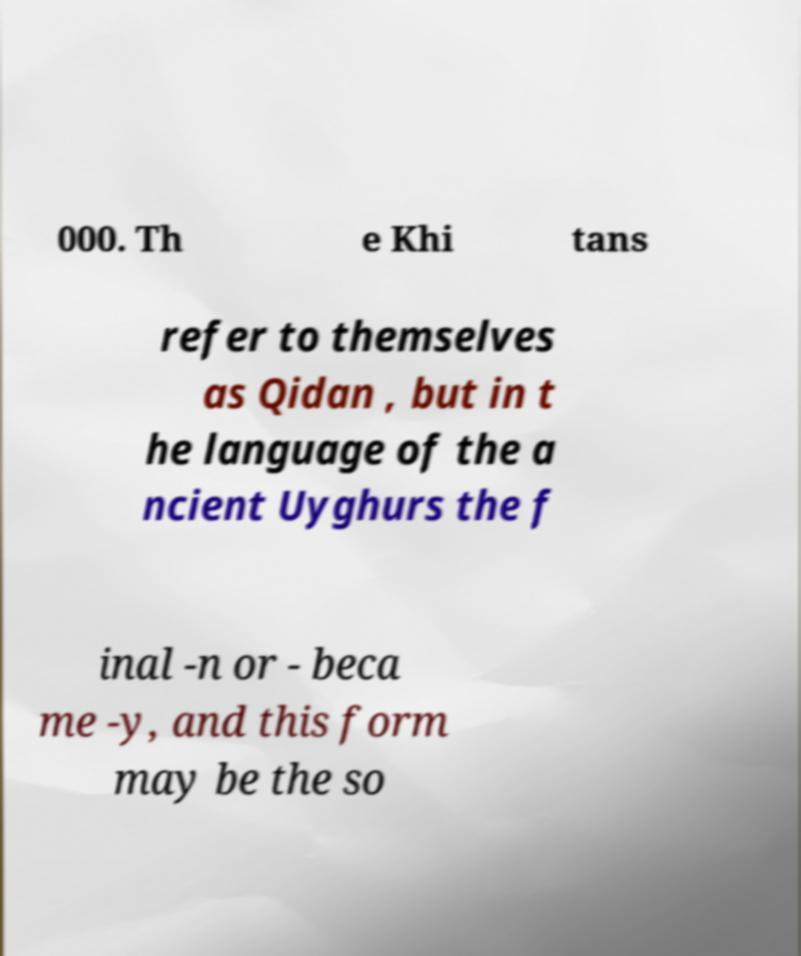Can you accurately transcribe the text from the provided image for me? 000. Th e Khi tans refer to themselves as Qidan , but in t he language of the a ncient Uyghurs the f inal -n or - beca me -y, and this form may be the so 